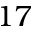<formula> <loc_0><loc_0><loc_500><loc_500>1 7</formula> 